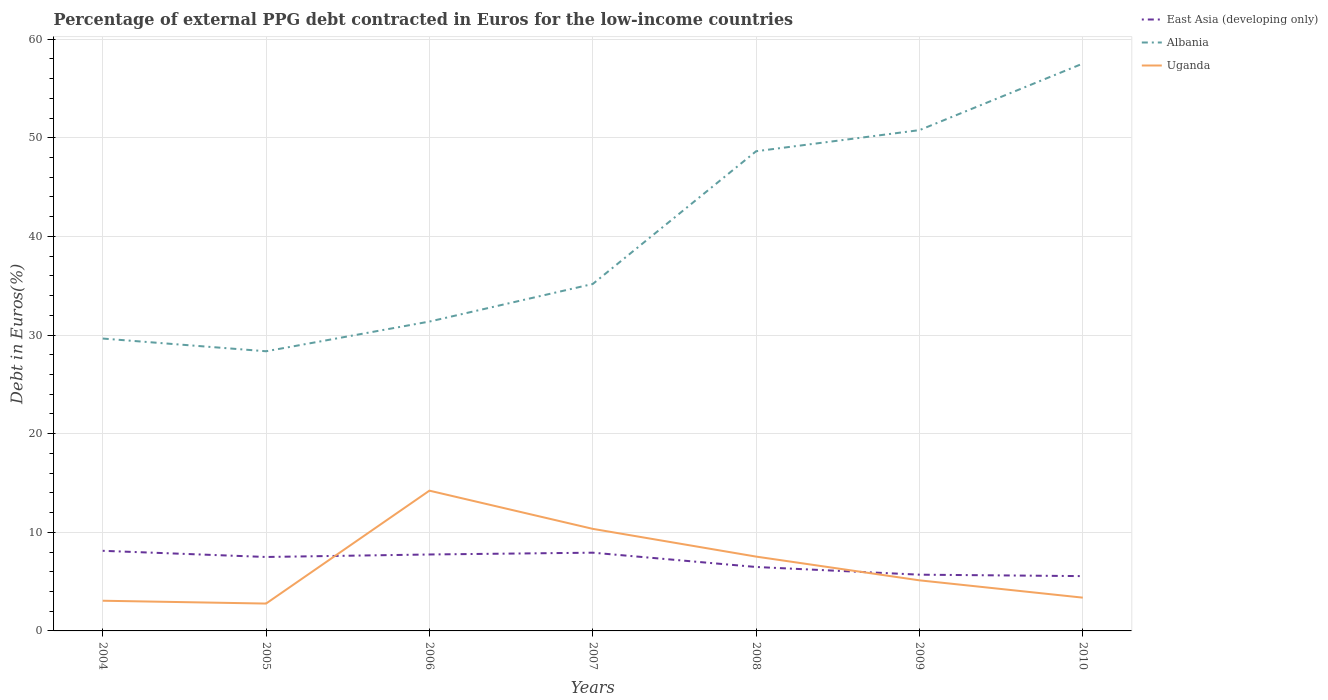Does the line corresponding to East Asia (developing only) intersect with the line corresponding to Uganda?
Provide a short and direct response. Yes. Across all years, what is the maximum percentage of external PPG debt contracted in Euros in East Asia (developing only)?
Your answer should be compact. 5.56. What is the total percentage of external PPG debt contracted in Euros in East Asia (developing only) in the graph?
Your answer should be compact. 1.45. What is the difference between the highest and the second highest percentage of external PPG debt contracted in Euros in East Asia (developing only)?
Offer a terse response. 2.57. Is the percentage of external PPG debt contracted in Euros in Uganda strictly greater than the percentage of external PPG debt contracted in Euros in Albania over the years?
Provide a short and direct response. Yes. How many lines are there?
Your answer should be compact. 3. What is the difference between two consecutive major ticks on the Y-axis?
Provide a short and direct response. 10. Are the values on the major ticks of Y-axis written in scientific E-notation?
Give a very brief answer. No. Does the graph contain grids?
Provide a short and direct response. Yes. What is the title of the graph?
Your answer should be compact. Percentage of external PPG debt contracted in Euros for the low-income countries. Does "Bermuda" appear as one of the legend labels in the graph?
Your answer should be compact. No. What is the label or title of the Y-axis?
Your response must be concise. Debt in Euros(%). What is the Debt in Euros(%) of East Asia (developing only) in 2004?
Your answer should be compact. 8.12. What is the Debt in Euros(%) of Albania in 2004?
Make the answer very short. 29.65. What is the Debt in Euros(%) in Uganda in 2004?
Give a very brief answer. 3.06. What is the Debt in Euros(%) of East Asia (developing only) in 2005?
Offer a terse response. 7.5. What is the Debt in Euros(%) of Albania in 2005?
Ensure brevity in your answer.  28.36. What is the Debt in Euros(%) of Uganda in 2005?
Offer a very short reply. 2.77. What is the Debt in Euros(%) in East Asia (developing only) in 2006?
Offer a terse response. 7.75. What is the Debt in Euros(%) in Albania in 2006?
Your answer should be very brief. 31.37. What is the Debt in Euros(%) in Uganda in 2006?
Provide a succinct answer. 14.22. What is the Debt in Euros(%) of East Asia (developing only) in 2007?
Provide a succinct answer. 7.93. What is the Debt in Euros(%) in Albania in 2007?
Make the answer very short. 35.18. What is the Debt in Euros(%) of Uganda in 2007?
Your response must be concise. 10.35. What is the Debt in Euros(%) in East Asia (developing only) in 2008?
Provide a short and direct response. 6.48. What is the Debt in Euros(%) in Albania in 2008?
Keep it short and to the point. 48.64. What is the Debt in Euros(%) in Uganda in 2008?
Keep it short and to the point. 7.54. What is the Debt in Euros(%) in East Asia (developing only) in 2009?
Give a very brief answer. 5.7. What is the Debt in Euros(%) of Albania in 2009?
Your answer should be very brief. 50.78. What is the Debt in Euros(%) in Uganda in 2009?
Provide a succinct answer. 5.13. What is the Debt in Euros(%) in East Asia (developing only) in 2010?
Make the answer very short. 5.56. What is the Debt in Euros(%) of Albania in 2010?
Offer a terse response. 57.53. What is the Debt in Euros(%) in Uganda in 2010?
Your answer should be very brief. 3.37. Across all years, what is the maximum Debt in Euros(%) in East Asia (developing only)?
Provide a short and direct response. 8.12. Across all years, what is the maximum Debt in Euros(%) in Albania?
Your response must be concise. 57.53. Across all years, what is the maximum Debt in Euros(%) in Uganda?
Ensure brevity in your answer.  14.22. Across all years, what is the minimum Debt in Euros(%) in East Asia (developing only)?
Your answer should be compact. 5.56. Across all years, what is the minimum Debt in Euros(%) of Albania?
Make the answer very short. 28.36. Across all years, what is the minimum Debt in Euros(%) in Uganda?
Give a very brief answer. 2.77. What is the total Debt in Euros(%) in East Asia (developing only) in the graph?
Make the answer very short. 49.05. What is the total Debt in Euros(%) of Albania in the graph?
Provide a short and direct response. 281.5. What is the total Debt in Euros(%) of Uganda in the graph?
Provide a succinct answer. 46.45. What is the difference between the Debt in Euros(%) of East Asia (developing only) in 2004 and that in 2005?
Offer a very short reply. 0.63. What is the difference between the Debt in Euros(%) in Albania in 2004 and that in 2005?
Keep it short and to the point. 1.29. What is the difference between the Debt in Euros(%) in Uganda in 2004 and that in 2005?
Make the answer very short. 0.29. What is the difference between the Debt in Euros(%) in East Asia (developing only) in 2004 and that in 2006?
Your answer should be very brief. 0.37. What is the difference between the Debt in Euros(%) in Albania in 2004 and that in 2006?
Offer a very short reply. -1.72. What is the difference between the Debt in Euros(%) in Uganda in 2004 and that in 2006?
Your answer should be very brief. -11.16. What is the difference between the Debt in Euros(%) in East Asia (developing only) in 2004 and that in 2007?
Give a very brief answer. 0.19. What is the difference between the Debt in Euros(%) of Albania in 2004 and that in 2007?
Give a very brief answer. -5.53. What is the difference between the Debt in Euros(%) of Uganda in 2004 and that in 2007?
Offer a very short reply. -7.29. What is the difference between the Debt in Euros(%) of East Asia (developing only) in 2004 and that in 2008?
Ensure brevity in your answer.  1.64. What is the difference between the Debt in Euros(%) in Albania in 2004 and that in 2008?
Keep it short and to the point. -18.99. What is the difference between the Debt in Euros(%) in Uganda in 2004 and that in 2008?
Give a very brief answer. -4.47. What is the difference between the Debt in Euros(%) in East Asia (developing only) in 2004 and that in 2009?
Your answer should be compact. 2.42. What is the difference between the Debt in Euros(%) of Albania in 2004 and that in 2009?
Provide a succinct answer. -21.13. What is the difference between the Debt in Euros(%) of Uganda in 2004 and that in 2009?
Give a very brief answer. -2.07. What is the difference between the Debt in Euros(%) of East Asia (developing only) in 2004 and that in 2010?
Your answer should be compact. 2.57. What is the difference between the Debt in Euros(%) of Albania in 2004 and that in 2010?
Give a very brief answer. -27.88. What is the difference between the Debt in Euros(%) in Uganda in 2004 and that in 2010?
Your answer should be very brief. -0.31. What is the difference between the Debt in Euros(%) in East Asia (developing only) in 2005 and that in 2006?
Ensure brevity in your answer.  -0.25. What is the difference between the Debt in Euros(%) in Albania in 2005 and that in 2006?
Make the answer very short. -3.01. What is the difference between the Debt in Euros(%) of Uganda in 2005 and that in 2006?
Provide a short and direct response. -11.45. What is the difference between the Debt in Euros(%) of East Asia (developing only) in 2005 and that in 2007?
Your response must be concise. -0.44. What is the difference between the Debt in Euros(%) of Albania in 2005 and that in 2007?
Make the answer very short. -6.82. What is the difference between the Debt in Euros(%) of Uganda in 2005 and that in 2007?
Your response must be concise. -7.57. What is the difference between the Debt in Euros(%) in East Asia (developing only) in 2005 and that in 2008?
Give a very brief answer. 1.01. What is the difference between the Debt in Euros(%) of Albania in 2005 and that in 2008?
Make the answer very short. -20.28. What is the difference between the Debt in Euros(%) in Uganda in 2005 and that in 2008?
Offer a very short reply. -4.76. What is the difference between the Debt in Euros(%) of East Asia (developing only) in 2005 and that in 2009?
Your answer should be compact. 1.79. What is the difference between the Debt in Euros(%) in Albania in 2005 and that in 2009?
Your answer should be compact. -22.42. What is the difference between the Debt in Euros(%) of Uganda in 2005 and that in 2009?
Give a very brief answer. -2.35. What is the difference between the Debt in Euros(%) of East Asia (developing only) in 2005 and that in 2010?
Provide a succinct answer. 1.94. What is the difference between the Debt in Euros(%) in Albania in 2005 and that in 2010?
Give a very brief answer. -29.17. What is the difference between the Debt in Euros(%) of Uganda in 2005 and that in 2010?
Offer a very short reply. -0.6. What is the difference between the Debt in Euros(%) of East Asia (developing only) in 2006 and that in 2007?
Offer a terse response. -0.18. What is the difference between the Debt in Euros(%) in Albania in 2006 and that in 2007?
Your response must be concise. -3.81. What is the difference between the Debt in Euros(%) of Uganda in 2006 and that in 2007?
Keep it short and to the point. 3.87. What is the difference between the Debt in Euros(%) of East Asia (developing only) in 2006 and that in 2008?
Keep it short and to the point. 1.27. What is the difference between the Debt in Euros(%) in Albania in 2006 and that in 2008?
Provide a succinct answer. -17.27. What is the difference between the Debt in Euros(%) in Uganda in 2006 and that in 2008?
Provide a short and direct response. 6.69. What is the difference between the Debt in Euros(%) of East Asia (developing only) in 2006 and that in 2009?
Provide a short and direct response. 2.05. What is the difference between the Debt in Euros(%) in Albania in 2006 and that in 2009?
Your answer should be very brief. -19.41. What is the difference between the Debt in Euros(%) of Uganda in 2006 and that in 2009?
Keep it short and to the point. 9.09. What is the difference between the Debt in Euros(%) of East Asia (developing only) in 2006 and that in 2010?
Your response must be concise. 2.19. What is the difference between the Debt in Euros(%) of Albania in 2006 and that in 2010?
Your response must be concise. -26.16. What is the difference between the Debt in Euros(%) of Uganda in 2006 and that in 2010?
Keep it short and to the point. 10.85. What is the difference between the Debt in Euros(%) in East Asia (developing only) in 2007 and that in 2008?
Your response must be concise. 1.45. What is the difference between the Debt in Euros(%) of Albania in 2007 and that in 2008?
Ensure brevity in your answer.  -13.46. What is the difference between the Debt in Euros(%) of Uganda in 2007 and that in 2008?
Provide a short and direct response. 2.81. What is the difference between the Debt in Euros(%) of East Asia (developing only) in 2007 and that in 2009?
Make the answer very short. 2.23. What is the difference between the Debt in Euros(%) of Albania in 2007 and that in 2009?
Make the answer very short. -15.6. What is the difference between the Debt in Euros(%) in Uganda in 2007 and that in 2009?
Your answer should be very brief. 5.22. What is the difference between the Debt in Euros(%) in East Asia (developing only) in 2007 and that in 2010?
Make the answer very short. 2.38. What is the difference between the Debt in Euros(%) of Albania in 2007 and that in 2010?
Give a very brief answer. -22.35. What is the difference between the Debt in Euros(%) of Uganda in 2007 and that in 2010?
Keep it short and to the point. 6.98. What is the difference between the Debt in Euros(%) of East Asia (developing only) in 2008 and that in 2009?
Keep it short and to the point. 0.78. What is the difference between the Debt in Euros(%) of Albania in 2008 and that in 2009?
Your answer should be very brief. -2.14. What is the difference between the Debt in Euros(%) of Uganda in 2008 and that in 2009?
Make the answer very short. 2.41. What is the difference between the Debt in Euros(%) of East Asia (developing only) in 2008 and that in 2010?
Provide a short and direct response. 0.93. What is the difference between the Debt in Euros(%) of Albania in 2008 and that in 2010?
Ensure brevity in your answer.  -8.89. What is the difference between the Debt in Euros(%) in Uganda in 2008 and that in 2010?
Provide a short and direct response. 4.16. What is the difference between the Debt in Euros(%) in East Asia (developing only) in 2009 and that in 2010?
Your response must be concise. 0.15. What is the difference between the Debt in Euros(%) of Albania in 2009 and that in 2010?
Offer a very short reply. -6.75. What is the difference between the Debt in Euros(%) in Uganda in 2009 and that in 2010?
Give a very brief answer. 1.76. What is the difference between the Debt in Euros(%) in East Asia (developing only) in 2004 and the Debt in Euros(%) in Albania in 2005?
Your response must be concise. -20.23. What is the difference between the Debt in Euros(%) of East Asia (developing only) in 2004 and the Debt in Euros(%) of Uganda in 2005?
Offer a very short reply. 5.35. What is the difference between the Debt in Euros(%) in Albania in 2004 and the Debt in Euros(%) in Uganda in 2005?
Offer a very short reply. 26.87. What is the difference between the Debt in Euros(%) of East Asia (developing only) in 2004 and the Debt in Euros(%) of Albania in 2006?
Your response must be concise. -23.25. What is the difference between the Debt in Euros(%) in East Asia (developing only) in 2004 and the Debt in Euros(%) in Uganda in 2006?
Ensure brevity in your answer.  -6.1. What is the difference between the Debt in Euros(%) in Albania in 2004 and the Debt in Euros(%) in Uganda in 2006?
Offer a very short reply. 15.42. What is the difference between the Debt in Euros(%) in East Asia (developing only) in 2004 and the Debt in Euros(%) in Albania in 2007?
Your answer should be very brief. -27.06. What is the difference between the Debt in Euros(%) of East Asia (developing only) in 2004 and the Debt in Euros(%) of Uganda in 2007?
Keep it short and to the point. -2.23. What is the difference between the Debt in Euros(%) in Albania in 2004 and the Debt in Euros(%) in Uganda in 2007?
Give a very brief answer. 19.3. What is the difference between the Debt in Euros(%) in East Asia (developing only) in 2004 and the Debt in Euros(%) in Albania in 2008?
Provide a succinct answer. -40.52. What is the difference between the Debt in Euros(%) of East Asia (developing only) in 2004 and the Debt in Euros(%) of Uganda in 2008?
Provide a succinct answer. 0.59. What is the difference between the Debt in Euros(%) in Albania in 2004 and the Debt in Euros(%) in Uganda in 2008?
Offer a very short reply. 22.11. What is the difference between the Debt in Euros(%) in East Asia (developing only) in 2004 and the Debt in Euros(%) in Albania in 2009?
Provide a succinct answer. -42.66. What is the difference between the Debt in Euros(%) in East Asia (developing only) in 2004 and the Debt in Euros(%) in Uganda in 2009?
Keep it short and to the point. 2.99. What is the difference between the Debt in Euros(%) of Albania in 2004 and the Debt in Euros(%) of Uganda in 2009?
Give a very brief answer. 24.52. What is the difference between the Debt in Euros(%) of East Asia (developing only) in 2004 and the Debt in Euros(%) of Albania in 2010?
Provide a succinct answer. -49.4. What is the difference between the Debt in Euros(%) of East Asia (developing only) in 2004 and the Debt in Euros(%) of Uganda in 2010?
Your answer should be compact. 4.75. What is the difference between the Debt in Euros(%) in Albania in 2004 and the Debt in Euros(%) in Uganda in 2010?
Keep it short and to the point. 26.27. What is the difference between the Debt in Euros(%) in East Asia (developing only) in 2005 and the Debt in Euros(%) in Albania in 2006?
Your answer should be compact. -23.87. What is the difference between the Debt in Euros(%) of East Asia (developing only) in 2005 and the Debt in Euros(%) of Uganda in 2006?
Your answer should be very brief. -6.72. What is the difference between the Debt in Euros(%) in Albania in 2005 and the Debt in Euros(%) in Uganda in 2006?
Offer a very short reply. 14.13. What is the difference between the Debt in Euros(%) of East Asia (developing only) in 2005 and the Debt in Euros(%) of Albania in 2007?
Your response must be concise. -27.68. What is the difference between the Debt in Euros(%) in East Asia (developing only) in 2005 and the Debt in Euros(%) in Uganda in 2007?
Give a very brief answer. -2.85. What is the difference between the Debt in Euros(%) of Albania in 2005 and the Debt in Euros(%) of Uganda in 2007?
Provide a short and direct response. 18.01. What is the difference between the Debt in Euros(%) in East Asia (developing only) in 2005 and the Debt in Euros(%) in Albania in 2008?
Your answer should be compact. -41.14. What is the difference between the Debt in Euros(%) in East Asia (developing only) in 2005 and the Debt in Euros(%) in Uganda in 2008?
Offer a terse response. -0.04. What is the difference between the Debt in Euros(%) of Albania in 2005 and the Debt in Euros(%) of Uganda in 2008?
Provide a short and direct response. 20.82. What is the difference between the Debt in Euros(%) of East Asia (developing only) in 2005 and the Debt in Euros(%) of Albania in 2009?
Your answer should be compact. -43.28. What is the difference between the Debt in Euros(%) in East Asia (developing only) in 2005 and the Debt in Euros(%) in Uganda in 2009?
Ensure brevity in your answer.  2.37. What is the difference between the Debt in Euros(%) in Albania in 2005 and the Debt in Euros(%) in Uganda in 2009?
Ensure brevity in your answer.  23.23. What is the difference between the Debt in Euros(%) of East Asia (developing only) in 2005 and the Debt in Euros(%) of Albania in 2010?
Your answer should be compact. -50.03. What is the difference between the Debt in Euros(%) in East Asia (developing only) in 2005 and the Debt in Euros(%) in Uganda in 2010?
Ensure brevity in your answer.  4.12. What is the difference between the Debt in Euros(%) in Albania in 2005 and the Debt in Euros(%) in Uganda in 2010?
Offer a terse response. 24.98. What is the difference between the Debt in Euros(%) in East Asia (developing only) in 2006 and the Debt in Euros(%) in Albania in 2007?
Keep it short and to the point. -27.43. What is the difference between the Debt in Euros(%) in East Asia (developing only) in 2006 and the Debt in Euros(%) in Uganda in 2007?
Make the answer very short. -2.6. What is the difference between the Debt in Euros(%) in Albania in 2006 and the Debt in Euros(%) in Uganda in 2007?
Your answer should be compact. 21.02. What is the difference between the Debt in Euros(%) of East Asia (developing only) in 2006 and the Debt in Euros(%) of Albania in 2008?
Your answer should be very brief. -40.89. What is the difference between the Debt in Euros(%) of East Asia (developing only) in 2006 and the Debt in Euros(%) of Uganda in 2008?
Provide a succinct answer. 0.21. What is the difference between the Debt in Euros(%) in Albania in 2006 and the Debt in Euros(%) in Uganda in 2008?
Your answer should be very brief. 23.83. What is the difference between the Debt in Euros(%) of East Asia (developing only) in 2006 and the Debt in Euros(%) of Albania in 2009?
Give a very brief answer. -43.03. What is the difference between the Debt in Euros(%) of East Asia (developing only) in 2006 and the Debt in Euros(%) of Uganda in 2009?
Offer a very short reply. 2.62. What is the difference between the Debt in Euros(%) of Albania in 2006 and the Debt in Euros(%) of Uganda in 2009?
Offer a terse response. 26.24. What is the difference between the Debt in Euros(%) in East Asia (developing only) in 2006 and the Debt in Euros(%) in Albania in 2010?
Your response must be concise. -49.78. What is the difference between the Debt in Euros(%) of East Asia (developing only) in 2006 and the Debt in Euros(%) of Uganda in 2010?
Your response must be concise. 4.38. What is the difference between the Debt in Euros(%) in Albania in 2006 and the Debt in Euros(%) in Uganda in 2010?
Make the answer very short. 27.99. What is the difference between the Debt in Euros(%) in East Asia (developing only) in 2007 and the Debt in Euros(%) in Albania in 2008?
Make the answer very short. -40.71. What is the difference between the Debt in Euros(%) of East Asia (developing only) in 2007 and the Debt in Euros(%) of Uganda in 2008?
Give a very brief answer. 0.4. What is the difference between the Debt in Euros(%) in Albania in 2007 and the Debt in Euros(%) in Uganda in 2008?
Ensure brevity in your answer.  27.64. What is the difference between the Debt in Euros(%) of East Asia (developing only) in 2007 and the Debt in Euros(%) of Albania in 2009?
Your answer should be compact. -42.85. What is the difference between the Debt in Euros(%) of East Asia (developing only) in 2007 and the Debt in Euros(%) of Uganda in 2009?
Give a very brief answer. 2.8. What is the difference between the Debt in Euros(%) in Albania in 2007 and the Debt in Euros(%) in Uganda in 2009?
Make the answer very short. 30.05. What is the difference between the Debt in Euros(%) of East Asia (developing only) in 2007 and the Debt in Euros(%) of Albania in 2010?
Give a very brief answer. -49.59. What is the difference between the Debt in Euros(%) in East Asia (developing only) in 2007 and the Debt in Euros(%) in Uganda in 2010?
Make the answer very short. 4.56. What is the difference between the Debt in Euros(%) in Albania in 2007 and the Debt in Euros(%) in Uganda in 2010?
Offer a terse response. 31.81. What is the difference between the Debt in Euros(%) of East Asia (developing only) in 2008 and the Debt in Euros(%) of Albania in 2009?
Your answer should be very brief. -44.3. What is the difference between the Debt in Euros(%) of East Asia (developing only) in 2008 and the Debt in Euros(%) of Uganda in 2009?
Your answer should be compact. 1.35. What is the difference between the Debt in Euros(%) in Albania in 2008 and the Debt in Euros(%) in Uganda in 2009?
Ensure brevity in your answer.  43.51. What is the difference between the Debt in Euros(%) of East Asia (developing only) in 2008 and the Debt in Euros(%) of Albania in 2010?
Your response must be concise. -51.05. What is the difference between the Debt in Euros(%) of East Asia (developing only) in 2008 and the Debt in Euros(%) of Uganda in 2010?
Ensure brevity in your answer.  3.11. What is the difference between the Debt in Euros(%) in Albania in 2008 and the Debt in Euros(%) in Uganda in 2010?
Make the answer very short. 45.27. What is the difference between the Debt in Euros(%) of East Asia (developing only) in 2009 and the Debt in Euros(%) of Albania in 2010?
Provide a succinct answer. -51.82. What is the difference between the Debt in Euros(%) in East Asia (developing only) in 2009 and the Debt in Euros(%) in Uganda in 2010?
Your answer should be compact. 2.33. What is the difference between the Debt in Euros(%) in Albania in 2009 and the Debt in Euros(%) in Uganda in 2010?
Ensure brevity in your answer.  47.41. What is the average Debt in Euros(%) of East Asia (developing only) per year?
Keep it short and to the point. 7.01. What is the average Debt in Euros(%) in Albania per year?
Keep it short and to the point. 40.21. What is the average Debt in Euros(%) of Uganda per year?
Ensure brevity in your answer.  6.64. In the year 2004, what is the difference between the Debt in Euros(%) of East Asia (developing only) and Debt in Euros(%) of Albania?
Make the answer very short. -21.52. In the year 2004, what is the difference between the Debt in Euros(%) of East Asia (developing only) and Debt in Euros(%) of Uganda?
Make the answer very short. 5.06. In the year 2004, what is the difference between the Debt in Euros(%) in Albania and Debt in Euros(%) in Uganda?
Offer a terse response. 26.58. In the year 2005, what is the difference between the Debt in Euros(%) of East Asia (developing only) and Debt in Euros(%) of Albania?
Make the answer very short. -20.86. In the year 2005, what is the difference between the Debt in Euros(%) in East Asia (developing only) and Debt in Euros(%) in Uganda?
Make the answer very short. 4.72. In the year 2005, what is the difference between the Debt in Euros(%) of Albania and Debt in Euros(%) of Uganda?
Provide a short and direct response. 25.58. In the year 2006, what is the difference between the Debt in Euros(%) of East Asia (developing only) and Debt in Euros(%) of Albania?
Offer a terse response. -23.62. In the year 2006, what is the difference between the Debt in Euros(%) of East Asia (developing only) and Debt in Euros(%) of Uganda?
Give a very brief answer. -6.47. In the year 2006, what is the difference between the Debt in Euros(%) in Albania and Debt in Euros(%) in Uganda?
Your response must be concise. 17.15. In the year 2007, what is the difference between the Debt in Euros(%) in East Asia (developing only) and Debt in Euros(%) in Albania?
Make the answer very short. -27.25. In the year 2007, what is the difference between the Debt in Euros(%) in East Asia (developing only) and Debt in Euros(%) in Uganda?
Offer a terse response. -2.42. In the year 2007, what is the difference between the Debt in Euros(%) in Albania and Debt in Euros(%) in Uganda?
Give a very brief answer. 24.83. In the year 2008, what is the difference between the Debt in Euros(%) of East Asia (developing only) and Debt in Euros(%) of Albania?
Your response must be concise. -42.16. In the year 2008, what is the difference between the Debt in Euros(%) of East Asia (developing only) and Debt in Euros(%) of Uganda?
Give a very brief answer. -1.05. In the year 2008, what is the difference between the Debt in Euros(%) of Albania and Debt in Euros(%) of Uganda?
Your answer should be compact. 41.1. In the year 2009, what is the difference between the Debt in Euros(%) of East Asia (developing only) and Debt in Euros(%) of Albania?
Make the answer very short. -45.08. In the year 2009, what is the difference between the Debt in Euros(%) in East Asia (developing only) and Debt in Euros(%) in Uganda?
Provide a short and direct response. 0.57. In the year 2009, what is the difference between the Debt in Euros(%) in Albania and Debt in Euros(%) in Uganda?
Ensure brevity in your answer.  45.65. In the year 2010, what is the difference between the Debt in Euros(%) of East Asia (developing only) and Debt in Euros(%) of Albania?
Offer a very short reply. -51.97. In the year 2010, what is the difference between the Debt in Euros(%) in East Asia (developing only) and Debt in Euros(%) in Uganda?
Keep it short and to the point. 2.18. In the year 2010, what is the difference between the Debt in Euros(%) of Albania and Debt in Euros(%) of Uganda?
Provide a succinct answer. 54.15. What is the ratio of the Debt in Euros(%) of East Asia (developing only) in 2004 to that in 2005?
Offer a very short reply. 1.08. What is the ratio of the Debt in Euros(%) of Albania in 2004 to that in 2005?
Make the answer very short. 1.05. What is the ratio of the Debt in Euros(%) of Uganda in 2004 to that in 2005?
Your answer should be compact. 1.1. What is the ratio of the Debt in Euros(%) of East Asia (developing only) in 2004 to that in 2006?
Offer a terse response. 1.05. What is the ratio of the Debt in Euros(%) in Albania in 2004 to that in 2006?
Make the answer very short. 0.95. What is the ratio of the Debt in Euros(%) of Uganda in 2004 to that in 2006?
Keep it short and to the point. 0.22. What is the ratio of the Debt in Euros(%) of Albania in 2004 to that in 2007?
Your answer should be very brief. 0.84. What is the ratio of the Debt in Euros(%) of Uganda in 2004 to that in 2007?
Offer a very short reply. 0.3. What is the ratio of the Debt in Euros(%) of East Asia (developing only) in 2004 to that in 2008?
Provide a short and direct response. 1.25. What is the ratio of the Debt in Euros(%) of Albania in 2004 to that in 2008?
Keep it short and to the point. 0.61. What is the ratio of the Debt in Euros(%) of Uganda in 2004 to that in 2008?
Provide a succinct answer. 0.41. What is the ratio of the Debt in Euros(%) in East Asia (developing only) in 2004 to that in 2009?
Make the answer very short. 1.42. What is the ratio of the Debt in Euros(%) of Albania in 2004 to that in 2009?
Provide a succinct answer. 0.58. What is the ratio of the Debt in Euros(%) in Uganda in 2004 to that in 2009?
Make the answer very short. 0.6. What is the ratio of the Debt in Euros(%) in East Asia (developing only) in 2004 to that in 2010?
Ensure brevity in your answer.  1.46. What is the ratio of the Debt in Euros(%) of Albania in 2004 to that in 2010?
Offer a terse response. 0.52. What is the ratio of the Debt in Euros(%) of Uganda in 2004 to that in 2010?
Your response must be concise. 0.91. What is the ratio of the Debt in Euros(%) in East Asia (developing only) in 2005 to that in 2006?
Keep it short and to the point. 0.97. What is the ratio of the Debt in Euros(%) of Albania in 2005 to that in 2006?
Keep it short and to the point. 0.9. What is the ratio of the Debt in Euros(%) in Uganda in 2005 to that in 2006?
Offer a very short reply. 0.2. What is the ratio of the Debt in Euros(%) in East Asia (developing only) in 2005 to that in 2007?
Give a very brief answer. 0.95. What is the ratio of the Debt in Euros(%) of Albania in 2005 to that in 2007?
Offer a terse response. 0.81. What is the ratio of the Debt in Euros(%) in Uganda in 2005 to that in 2007?
Your answer should be compact. 0.27. What is the ratio of the Debt in Euros(%) in East Asia (developing only) in 2005 to that in 2008?
Provide a short and direct response. 1.16. What is the ratio of the Debt in Euros(%) of Albania in 2005 to that in 2008?
Offer a terse response. 0.58. What is the ratio of the Debt in Euros(%) in Uganda in 2005 to that in 2008?
Your answer should be very brief. 0.37. What is the ratio of the Debt in Euros(%) in East Asia (developing only) in 2005 to that in 2009?
Give a very brief answer. 1.31. What is the ratio of the Debt in Euros(%) of Albania in 2005 to that in 2009?
Offer a terse response. 0.56. What is the ratio of the Debt in Euros(%) of Uganda in 2005 to that in 2009?
Your answer should be compact. 0.54. What is the ratio of the Debt in Euros(%) in East Asia (developing only) in 2005 to that in 2010?
Your answer should be very brief. 1.35. What is the ratio of the Debt in Euros(%) of Albania in 2005 to that in 2010?
Make the answer very short. 0.49. What is the ratio of the Debt in Euros(%) of Uganda in 2005 to that in 2010?
Provide a succinct answer. 0.82. What is the ratio of the Debt in Euros(%) in East Asia (developing only) in 2006 to that in 2007?
Keep it short and to the point. 0.98. What is the ratio of the Debt in Euros(%) of Albania in 2006 to that in 2007?
Provide a short and direct response. 0.89. What is the ratio of the Debt in Euros(%) in Uganda in 2006 to that in 2007?
Your answer should be very brief. 1.37. What is the ratio of the Debt in Euros(%) of East Asia (developing only) in 2006 to that in 2008?
Provide a short and direct response. 1.2. What is the ratio of the Debt in Euros(%) of Albania in 2006 to that in 2008?
Provide a short and direct response. 0.64. What is the ratio of the Debt in Euros(%) in Uganda in 2006 to that in 2008?
Keep it short and to the point. 1.89. What is the ratio of the Debt in Euros(%) in East Asia (developing only) in 2006 to that in 2009?
Keep it short and to the point. 1.36. What is the ratio of the Debt in Euros(%) in Albania in 2006 to that in 2009?
Your response must be concise. 0.62. What is the ratio of the Debt in Euros(%) of Uganda in 2006 to that in 2009?
Keep it short and to the point. 2.77. What is the ratio of the Debt in Euros(%) in East Asia (developing only) in 2006 to that in 2010?
Offer a very short reply. 1.39. What is the ratio of the Debt in Euros(%) of Albania in 2006 to that in 2010?
Your answer should be compact. 0.55. What is the ratio of the Debt in Euros(%) in Uganda in 2006 to that in 2010?
Provide a short and direct response. 4.22. What is the ratio of the Debt in Euros(%) in East Asia (developing only) in 2007 to that in 2008?
Offer a very short reply. 1.22. What is the ratio of the Debt in Euros(%) of Albania in 2007 to that in 2008?
Your response must be concise. 0.72. What is the ratio of the Debt in Euros(%) in Uganda in 2007 to that in 2008?
Provide a succinct answer. 1.37. What is the ratio of the Debt in Euros(%) in East Asia (developing only) in 2007 to that in 2009?
Make the answer very short. 1.39. What is the ratio of the Debt in Euros(%) of Albania in 2007 to that in 2009?
Your answer should be compact. 0.69. What is the ratio of the Debt in Euros(%) of Uganda in 2007 to that in 2009?
Offer a terse response. 2.02. What is the ratio of the Debt in Euros(%) in East Asia (developing only) in 2007 to that in 2010?
Make the answer very short. 1.43. What is the ratio of the Debt in Euros(%) in Albania in 2007 to that in 2010?
Ensure brevity in your answer.  0.61. What is the ratio of the Debt in Euros(%) in Uganda in 2007 to that in 2010?
Give a very brief answer. 3.07. What is the ratio of the Debt in Euros(%) in East Asia (developing only) in 2008 to that in 2009?
Ensure brevity in your answer.  1.14. What is the ratio of the Debt in Euros(%) of Albania in 2008 to that in 2009?
Your answer should be compact. 0.96. What is the ratio of the Debt in Euros(%) of Uganda in 2008 to that in 2009?
Ensure brevity in your answer.  1.47. What is the ratio of the Debt in Euros(%) in East Asia (developing only) in 2008 to that in 2010?
Give a very brief answer. 1.17. What is the ratio of the Debt in Euros(%) in Albania in 2008 to that in 2010?
Give a very brief answer. 0.85. What is the ratio of the Debt in Euros(%) of Uganda in 2008 to that in 2010?
Give a very brief answer. 2.23. What is the ratio of the Debt in Euros(%) of East Asia (developing only) in 2009 to that in 2010?
Provide a succinct answer. 1.03. What is the ratio of the Debt in Euros(%) of Albania in 2009 to that in 2010?
Provide a succinct answer. 0.88. What is the ratio of the Debt in Euros(%) of Uganda in 2009 to that in 2010?
Provide a short and direct response. 1.52. What is the difference between the highest and the second highest Debt in Euros(%) in East Asia (developing only)?
Provide a short and direct response. 0.19. What is the difference between the highest and the second highest Debt in Euros(%) in Albania?
Your answer should be very brief. 6.75. What is the difference between the highest and the second highest Debt in Euros(%) of Uganda?
Keep it short and to the point. 3.87. What is the difference between the highest and the lowest Debt in Euros(%) of East Asia (developing only)?
Keep it short and to the point. 2.57. What is the difference between the highest and the lowest Debt in Euros(%) of Albania?
Make the answer very short. 29.17. What is the difference between the highest and the lowest Debt in Euros(%) in Uganda?
Your answer should be compact. 11.45. 